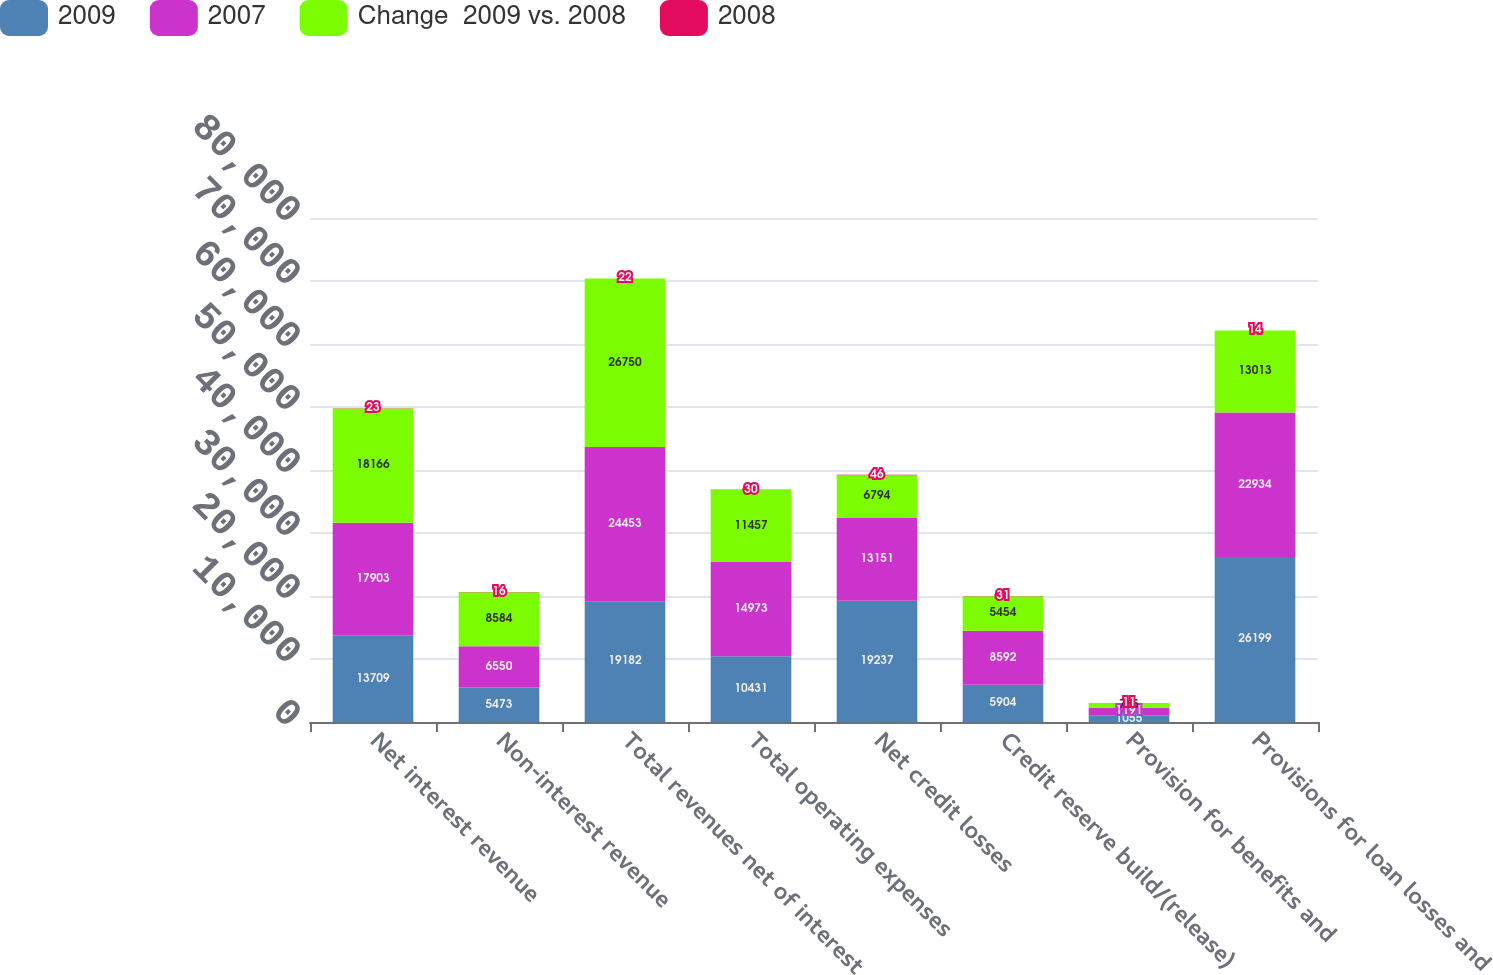<chart> <loc_0><loc_0><loc_500><loc_500><stacked_bar_chart><ecel><fcel>Net interest revenue<fcel>Non-interest revenue<fcel>Total revenues net of interest<fcel>Total operating expenses<fcel>Net credit losses<fcel>Credit reserve build/(release)<fcel>Provision for benefits and<fcel>Provisions for loan losses and<nl><fcel>2009<fcel>13709<fcel>5473<fcel>19182<fcel>10431<fcel>19237<fcel>5904<fcel>1055<fcel>26199<nl><fcel>2007<fcel>17903<fcel>6550<fcel>24453<fcel>14973<fcel>13151<fcel>8592<fcel>1191<fcel>22934<nl><fcel>Change  2009 vs. 2008<fcel>18166<fcel>8584<fcel>26750<fcel>11457<fcel>6794<fcel>5454<fcel>765<fcel>13013<nl><fcel>2008<fcel>23<fcel>16<fcel>22<fcel>30<fcel>46<fcel>31<fcel>11<fcel>14<nl></chart> 